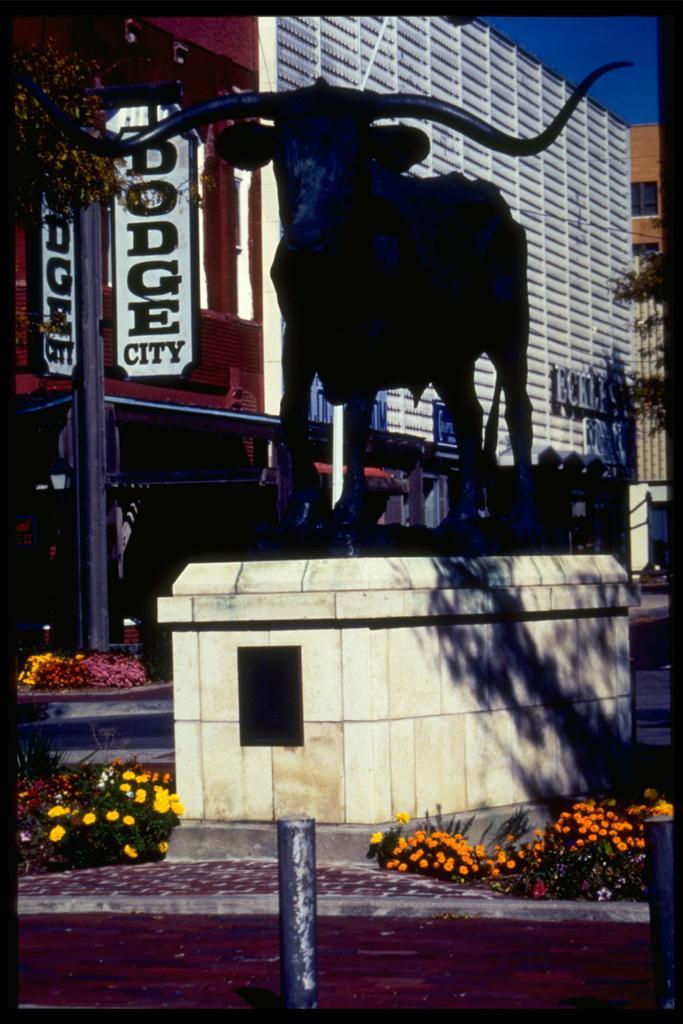How would you summarize this image in a sentence or two? In the foreground we can see small poles on the sideways of the road. Here we can see the flowers on the left side and the right side as well. Here we can see the statue of a bull. Here we can see a pole on the left side. In the background, we can see the buildings and trees. 